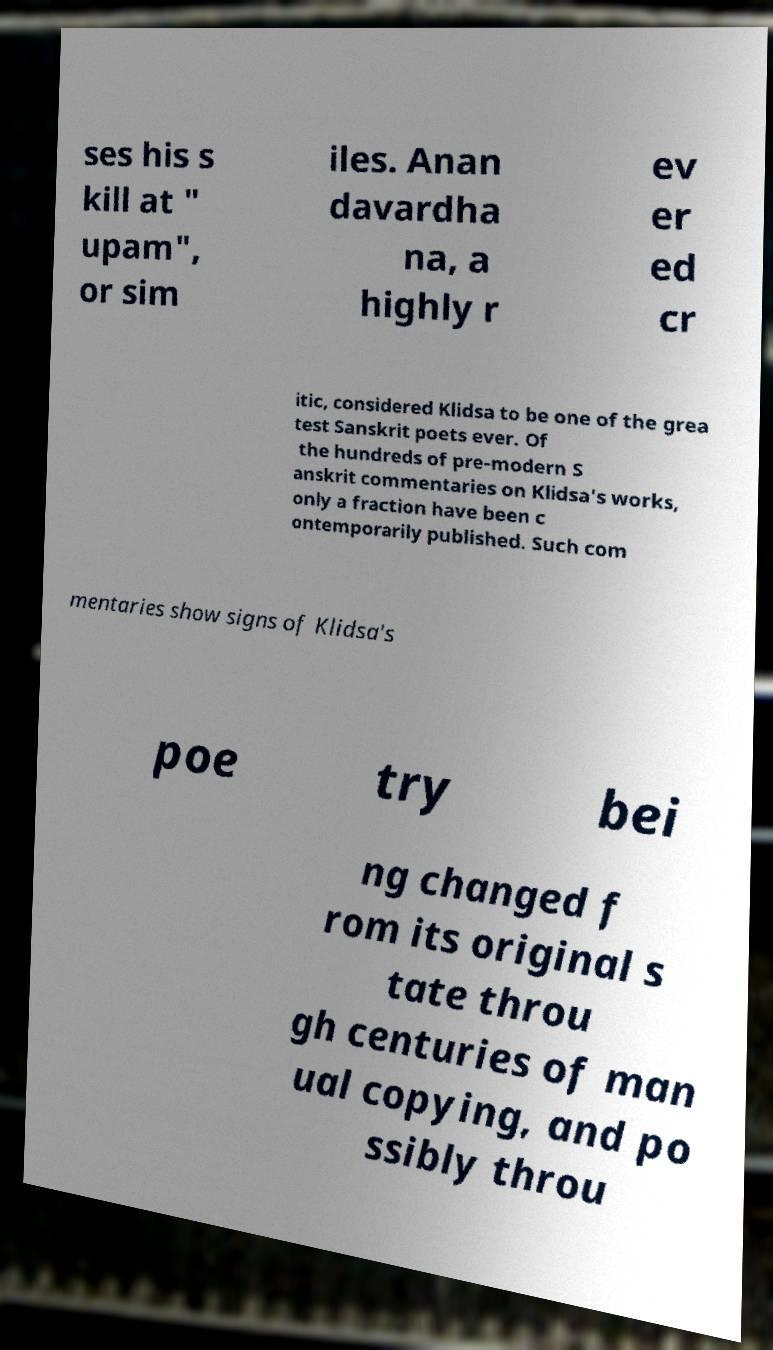There's text embedded in this image that I need extracted. Can you transcribe it verbatim? ses his s kill at " upam", or sim iles. Anan davardha na, a highly r ev er ed cr itic, considered Klidsa to be one of the grea test Sanskrit poets ever. Of the hundreds of pre-modern S anskrit commentaries on Klidsa's works, only a fraction have been c ontemporarily published. Such com mentaries show signs of Klidsa's poe try bei ng changed f rom its original s tate throu gh centuries of man ual copying, and po ssibly throu 